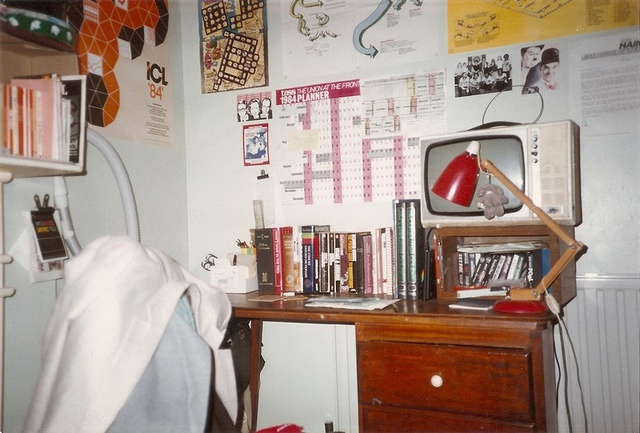Describe the objects in this image and their specific colors. I can see chair in black, lightgray, and darkgray tones, tv in black, darkgray, lightgray, and gray tones, book in black, lightgray, darkgray, gray, and brown tones, book in black, tan, salmon, and brown tones, and book in black, lightpink, lightgray, darkgray, and salmon tones in this image. 